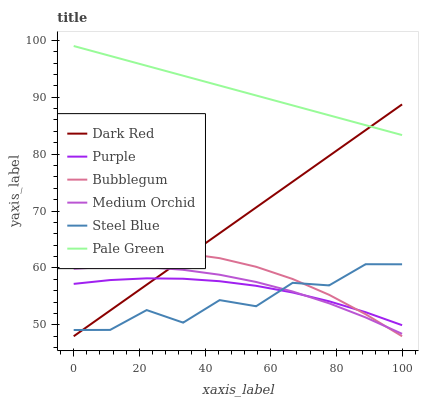Does Steel Blue have the minimum area under the curve?
Answer yes or no. Yes. Does Pale Green have the maximum area under the curve?
Answer yes or no. Yes. Does Dark Red have the minimum area under the curve?
Answer yes or no. No. Does Dark Red have the maximum area under the curve?
Answer yes or no. No. Is Dark Red the smoothest?
Answer yes or no. Yes. Is Steel Blue the roughest?
Answer yes or no. Yes. Is Medium Orchid the smoothest?
Answer yes or no. No. Is Medium Orchid the roughest?
Answer yes or no. No. Does Dark Red have the lowest value?
Answer yes or no. Yes. Does Medium Orchid have the lowest value?
Answer yes or no. No. Does Pale Green have the highest value?
Answer yes or no. Yes. Does Dark Red have the highest value?
Answer yes or no. No. Is Purple less than Pale Green?
Answer yes or no. Yes. Is Pale Green greater than Medium Orchid?
Answer yes or no. Yes. Does Bubblegum intersect Dark Red?
Answer yes or no. Yes. Is Bubblegum less than Dark Red?
Answer yes or no. No. Is Bubblegum greater than Dark Red?
Answer yes or no. No. Does Purple intersect Pale Green?
Answer yes or no. No. 